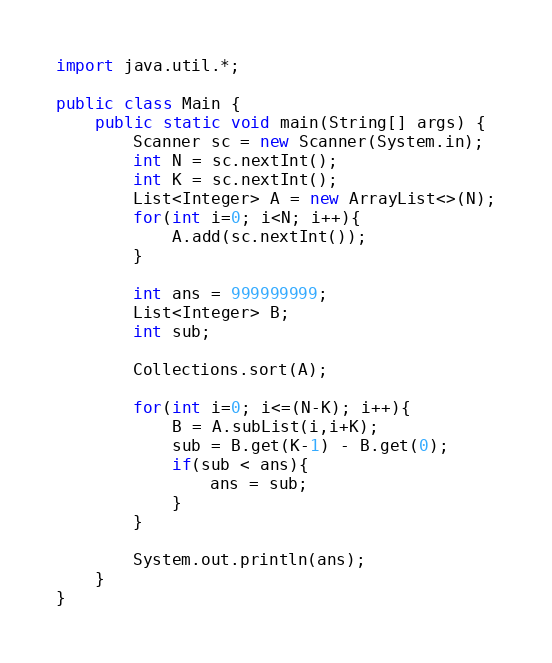<code> <loc_0><loc_0><loc_500><loc_500><_Java_>import java.util.*;

public class Main {
    public static void main(String[] args) {
        Scanner sc = new Scanner(System.in);
        int N = sc.nextInt();
        int K = sc.nextInt();
        List<Integer> A = new ArrayList<>(N);
        for(int i=0; i<N; i++){
            A.add(sc.nextInt());
        }

        int ans = 999999999;
        List<Integer> B;
        int sub;

        Collections.sort(A);

        for(int i=0; i<=(N-K); i++){
            B = A.subList(i,i+K);
            sub = B.get(K-1) - B.get(0);
            if(sub < ans){
                ans = sub;
            }
        }

        System.out.println(ans);
    }
}
</code> 